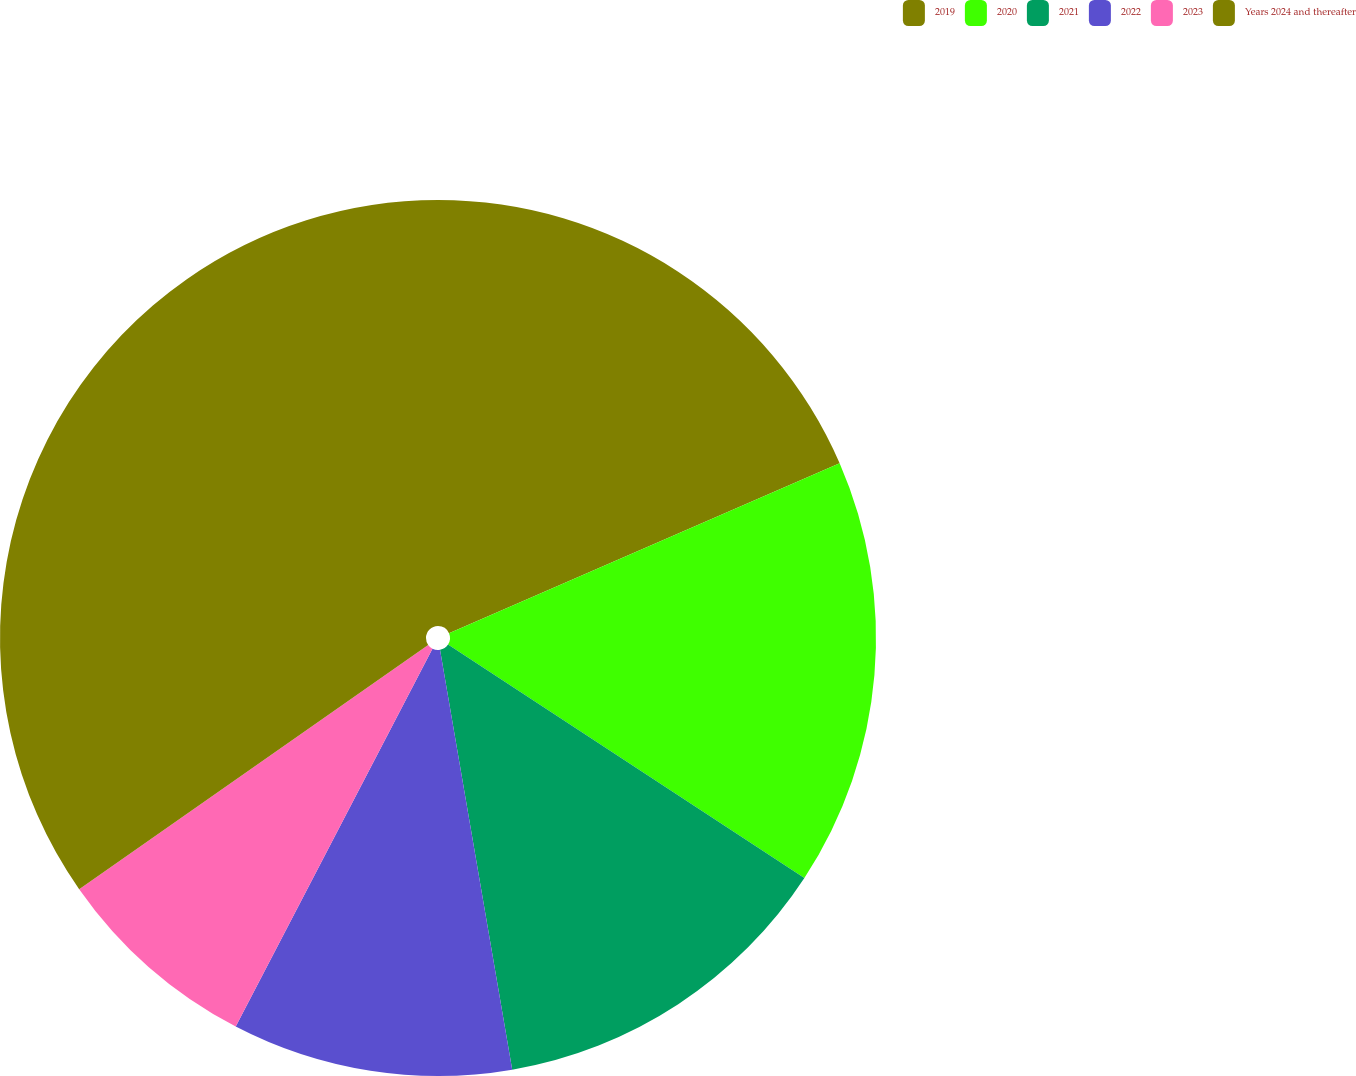Convert chart to OTSL. <chart><loc_0><loc_0><loc_500><loc_500><pie_chart><fcel>2019<fcel>2020<fcel>2021<fcel>2022<fcel>2023<fcel>Years 2024 and thereafter<nl><fcel>18.47%<fcel>15.76%<fcel>13.06%<fcel>10.35%<fcel>7.64%<fcel>34.72%<nl></chart> 